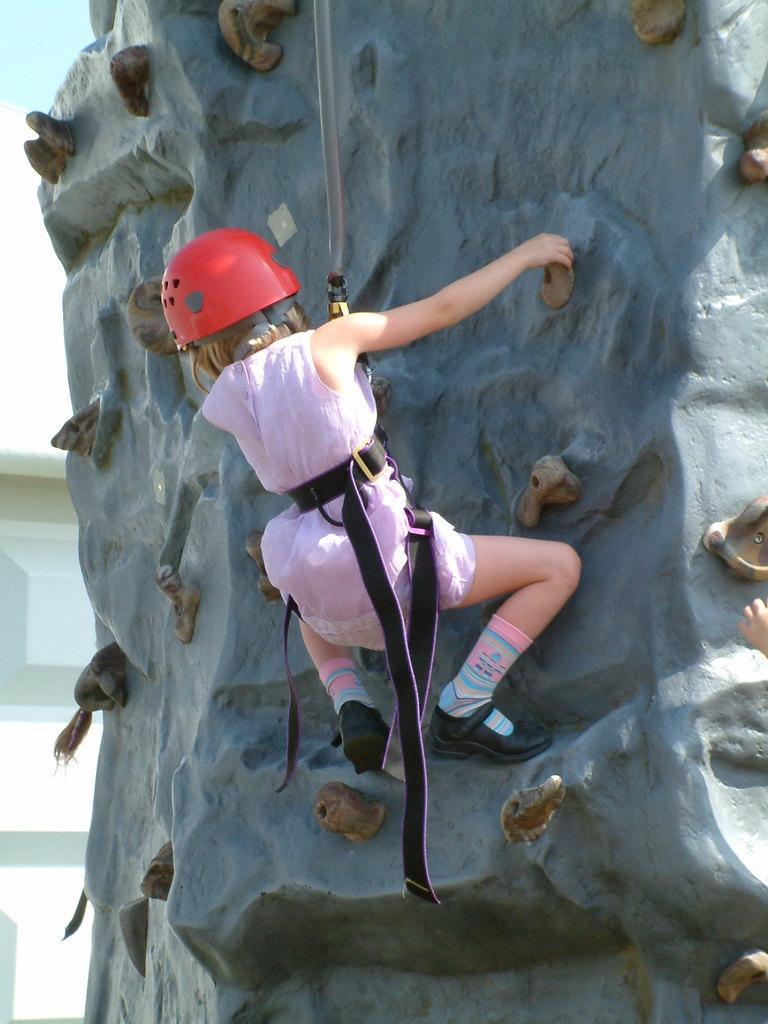How would you summarize this image in a sentence or two? A person is sport climbing wearing a pink dress, red helmet and black shoes. There is a white door at the back. 